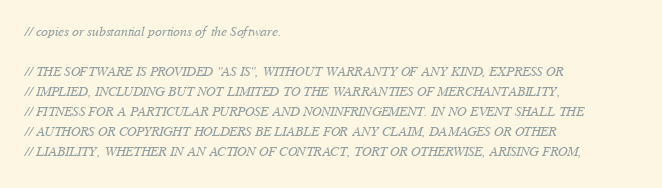<code> <loc_0><loc_0><loc_500><loc_500><_ObjectiveC_>// copies or substantial portions of the Software.

// THE SOFTWARE IS PROVIDED "AS IS", WITHOUT WARRANTY OF ANY KIND, EXPRESS OR
// IMPLIED, INCLUDING BUT NOT LIMITED TO THE WARRANTIES OF MERCHANTABILITY,
// FITNESS FOR A PARTICULAR PURPOSE AND NONINFRINGEMENT. IN NO EVENT SHALL THE
// AUTHORS OR COPYRIGHT HOLDERS BE LIABLE FOR ANY CLAIM, DAMAGES OR OTHER
// LIABILITY, WHETHER IN AN ACTION OF CONTRACT, TORT OR OTHERWISE, ARISING FROM,</code> 